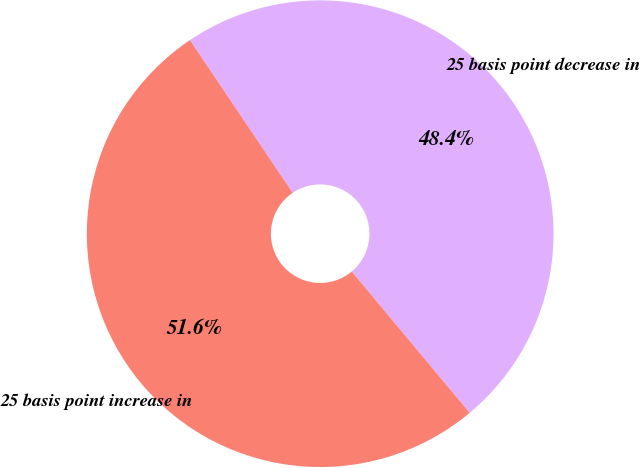<chart> <loc_0><loc_0><loc_500><loc_500><pie_chart><fcel>25 basis point decrease in<fcel>25 basis point increase in<nl><fcel>48.36%<fcel>51.64%<nl></chart> 